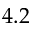<formula> <loc_0><loc_0><loc_500><loc_500>4 . 2</formula> 